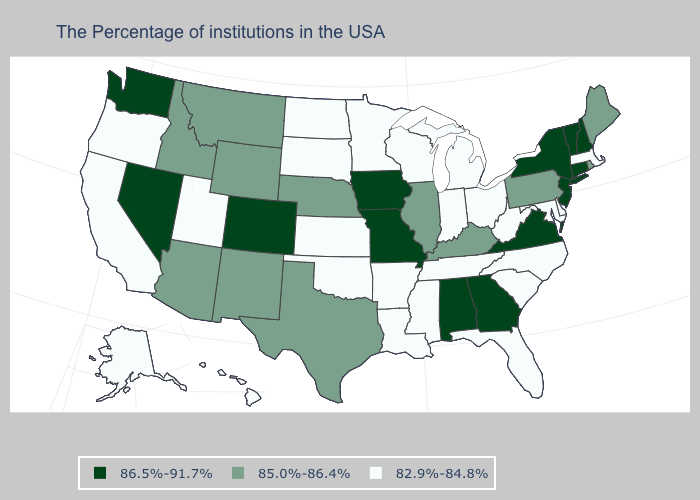What is the value of South Dakota?
Write a very short answer. 82.9%-84.8%. What is the value of Minnesota?
Be succinct. 82.9%-84.8%. How many symbols are there in the legend?
Be succinct. 3. What is the lowest value in states that border Delaware?
Keep it brief. 82.9%-84.8%. Does Texas have the same value as Rhode Island?
Quick response, please. Yes. What is the lowest value in the South?
Give a very brief answer. 82.9%-84.8%. What is the value of Connecticut?
Keep it brief. 86.5%-91.7%. Among the states that border Maryland , which have the highest value?
Concise answer only. Virginia. What is the value of Nebraska?
Write a very short answer. 85.0%-86.4%. Among the states that border Nevada , which have the lowest value?
Keep it brief. Utah, California, Oregon. Does Connecticut have the highest value in the USA?
Short answer required. Yes. What is the lowest value in states that border Tennessee?
Keep it brief. 82.9%-84.8%. Does the first symbol in the legend represent the smallest category?
Short answer required. No. What is the value of Maine?
Keep it brief. 85.0%-86.4%. What is the value of Arizona?
Give a very brief answer. 85.0%-86.4%. 